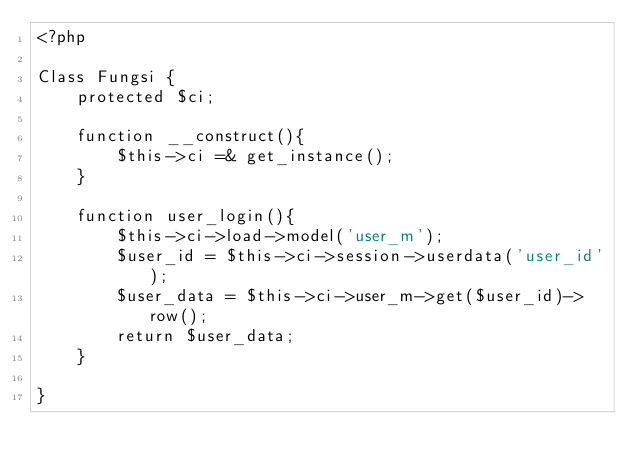<code> <loc_0><loc_0><loc_500><loc_500><_PHP_><?php

Class Fungsi {
	protected $ci;

	function __construct(){
		$this->ci =& get_instance();
	}

	function user_login(){
		$this->ci->load->model('user_m');
		$user_id = $this->ci->session->userdata('user_id');
		$user_data = $this->ci->user_m->get($user_id)->row();
		return $user_data; 
	}

}
</code> 